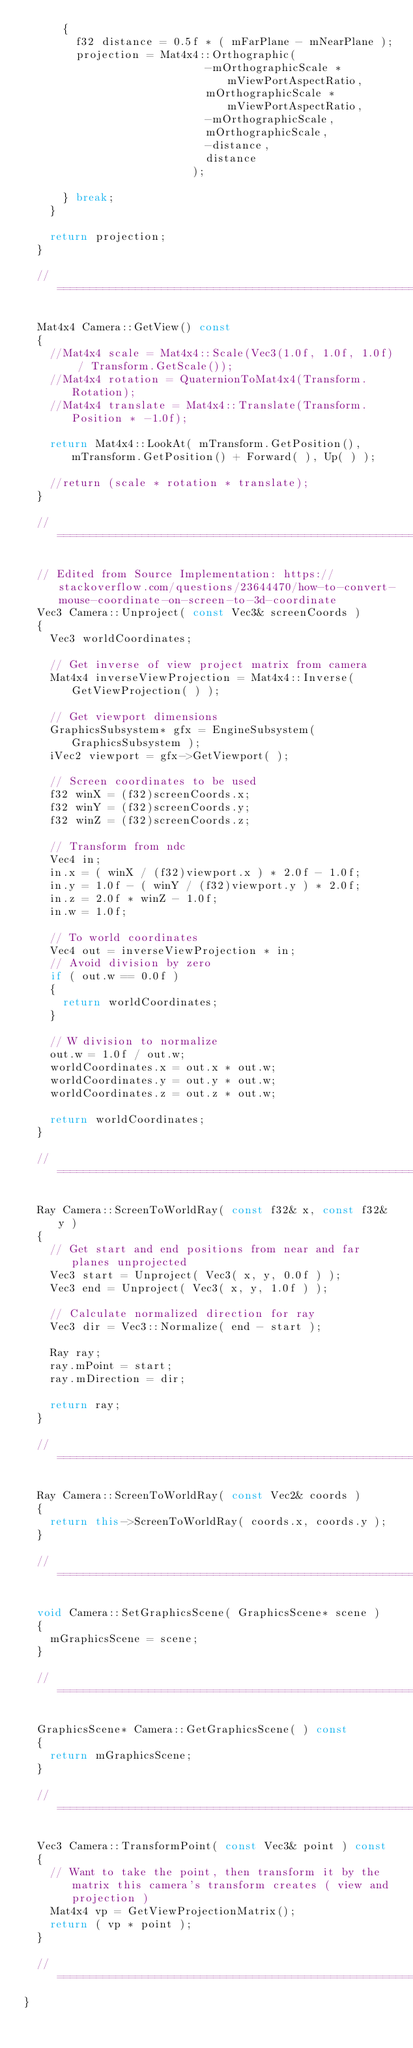Convert code to text. <code><loc_0><loc_0><loc_500><loc_500><_C++_>			{
				f32 distance = 0.5f * ( mFarPlane - mNearPlane );
				projection = Mat4x4::Orthographic(
														-mOrthographicScale * mViewPortAspectRatio, 
														mOrthographicScale * mViewPortAspectRatio, 
														-mOrthographicScale, 
														mOrthographicScale, 
														-distance, 
														distance	
													);

			} break;
		}

		return projection;
	}

	//=======================================================================================================

	Mat4x4 Camera::GetView() const
	{ 
		//Mat4x4 scale = Mat4x4::Scale(Vec3(1.0f, 1.0f, 1.0f) / Transform.GetScale());
		//Mat4x4 rotation = QuaternionToMat4x4(Transform.Rotation);
		//Mat4x4 translate = Mat4x4::Translate(Transform.Position * -1.0f); 

		return Mat4x4::LookAt( mTransform.GetPosition(), mTransform.GetPosition() + Forward( ), Up( ) );

		//return (scale * rotation * translate);
	}

	//=======================================================================================================

	// Edited from Source Implementation: https://stackoverflow.com/questions/23644470/how-to-convert-mouse-coordinate-on-screen-to-3d-coordinate
	Vec3 Camera::Unproject( const Vec3& screenCoords )
	{
		Vec3 worldCoordinates;

		// Get inverse of view project matrix from camera
		Mat4x4 inverseViewProjection = Mat4x4::Inverse( GetViewProjection( ) );

		// Get viewport dimensions
		GraphicsSubsystem* gfx = EngineSubsystem( GraphicsSubsystem );
		iVec2 viewport = gfx->GetViewport( );

		// Screen coordinates to be used
		f32 winX = (f32)screenCoords.x;
		f32 winY = (f32)screenCoords.y;
		f32 winZ = (f32)screenCoords.z;

		// Transform from ndc
		Vec4 in;
		in.x = ( winX / (f32)viewport.x ) * 2.0f - 1.0f;
		in.y = 1.0f - ( winY / (f32)viewport.y ) * 2.0f;
		in.z = 2.0f * winZ - 1.0f;
		in.w = 1.0f; 

		// To world coordinates
		Vec4 out = inverseViewProjection * in;
		// Avoid division by zero
		if ( out.w == 0.0f )
		{
			return worldCoordinates; 
		}

		// W division to normalize
		out.w = 1.0f / out.w;
		worldCoordinates.x = out.x * out.w;
		worldCoordinates.y = out.y * out.w;
		worldCoordinates.z = out.z * out.w; 

		return worldCoordinates;
	}

	//=======================================================================================================

	Ray Camera::ScreenToWorldRay( const f32& x, const f32& y )
	{
		// Get start and end positions from near and far planes unprojected
		Vec3 start = Unproject( Vec3( x, y, 0.0f ) );
		Vec3 end = Unproject( Vec3( x, y, 1.0f ) );

		// Calculate normalized direction for ray
		Vec3 dir = Vec3::Normalize( end - start );

		Ray ray;
		ray.mPoint = start;
		ray.mDirection = dir;

		return ray; 
	}

	//=======================================================================================================

	Ray Camera::ScreenToWorldRay( const Vec2& coords )
	{
		return this->ScreenToWorldRay( coords.x, coords.y );
	}

	//=======================================================================================================

	void Camera::SetGraphicsScene( GraphicsScene* scene )
	{
		mGraphicsScene = scene;
	}

	//=======================================================================================================

	GraphicsScene* Camera::GetGraphicsScene( ) const
	{
		return mGraphicsScene;
	} 

	//=======================================================================================================

	Vec3 Camera::TransformPoint( const Vec3& point ) const
	{
		// Want to take the point, then transform it by the matrix this camera's transform creates ( view and projection )
		Mat4x4 vp = GetViewProjectionMatrix(); 
		return ( vp * point ); 
	}

	//=======================================================================================================
}






















</code> 